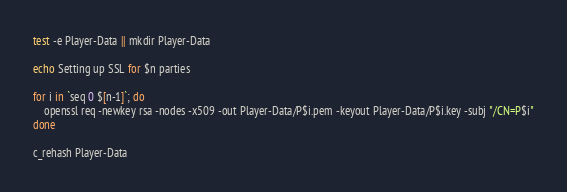<code> <loc_0><loc_0><loc_500><loc_500><_Bash_>
test -e Player-Data || mkdir Player-Data

echo Setting up SSL for $n parties

for i in `seq 0 $[n-1]`; do
    openssl req -newkey rsa -nodes -x509 -out Player-Data/P$i.pem -keyout Player-Data/P$i.key -subj "/CN=P$i"
done

c_rehash Player-Data
</code> 